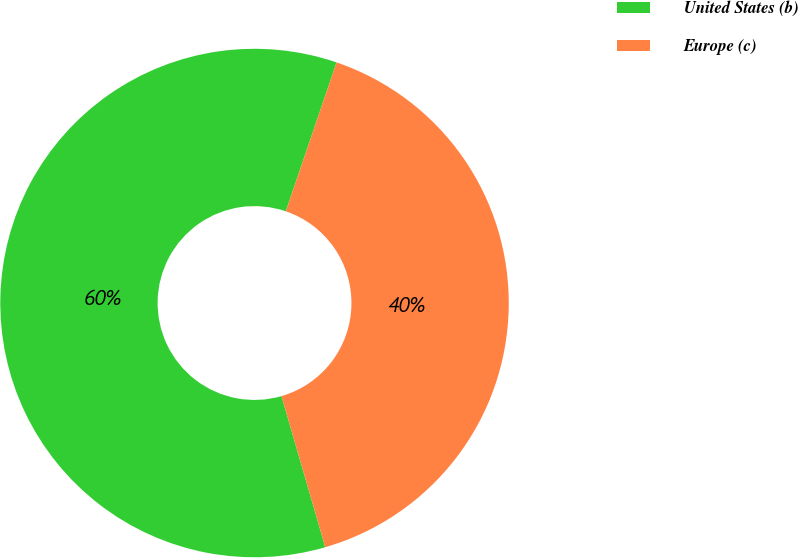Convert chart. <chart><loc_0><loc_0><loc_500><loc_500><pie_chart><fcel>United States (b)<fcel>Europe (c)<nl><fcel>59.72%<fcel>40.28%<nl></chart> 